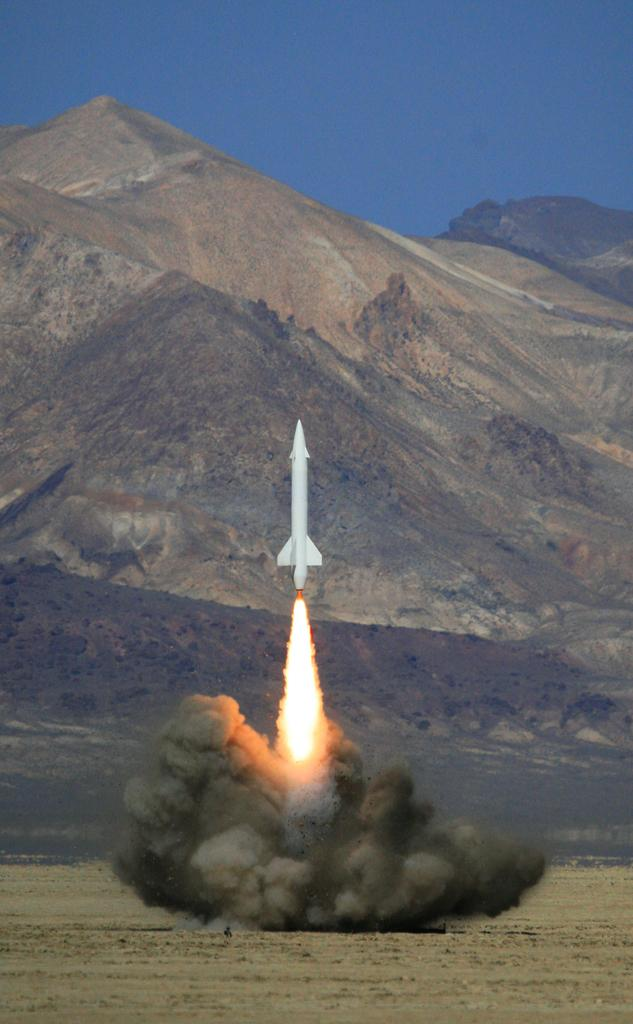What is the main subject of the image? The main subject of the image is a rocket. What is the rocket doing in the image? The rocket has blasted off into the sky. What can be seen in the background of the image? There are mountains visible in the background of the image. What type of mailbox can be seen near the rocket in the image? There is no mailbox present in the image; the main subject is a rocket that has blasted off into the sky. What is the purpose of the protest happening in the image? There is no protest depicted in the image; it features a rocket blasting off into the sky with mountains in the background. 